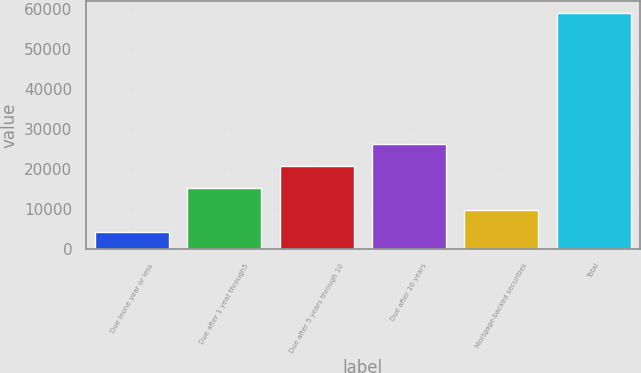Convert chart. <chart><loc_0><loc_0><loc_500><loc_500><bar_chart><fcel>Due inone year or less<fcel>Due after 1 year through5<fcel>Due after 5 years through 10<fcel>Due after 10 years<fcel>Mortgage-backed securities<fcel>Total<nl><fcel>4290<fcel>15228.6<fcel>20697.9<fcel>26167.2<fcel>9759.3<fcel>58983<nl></chart> 